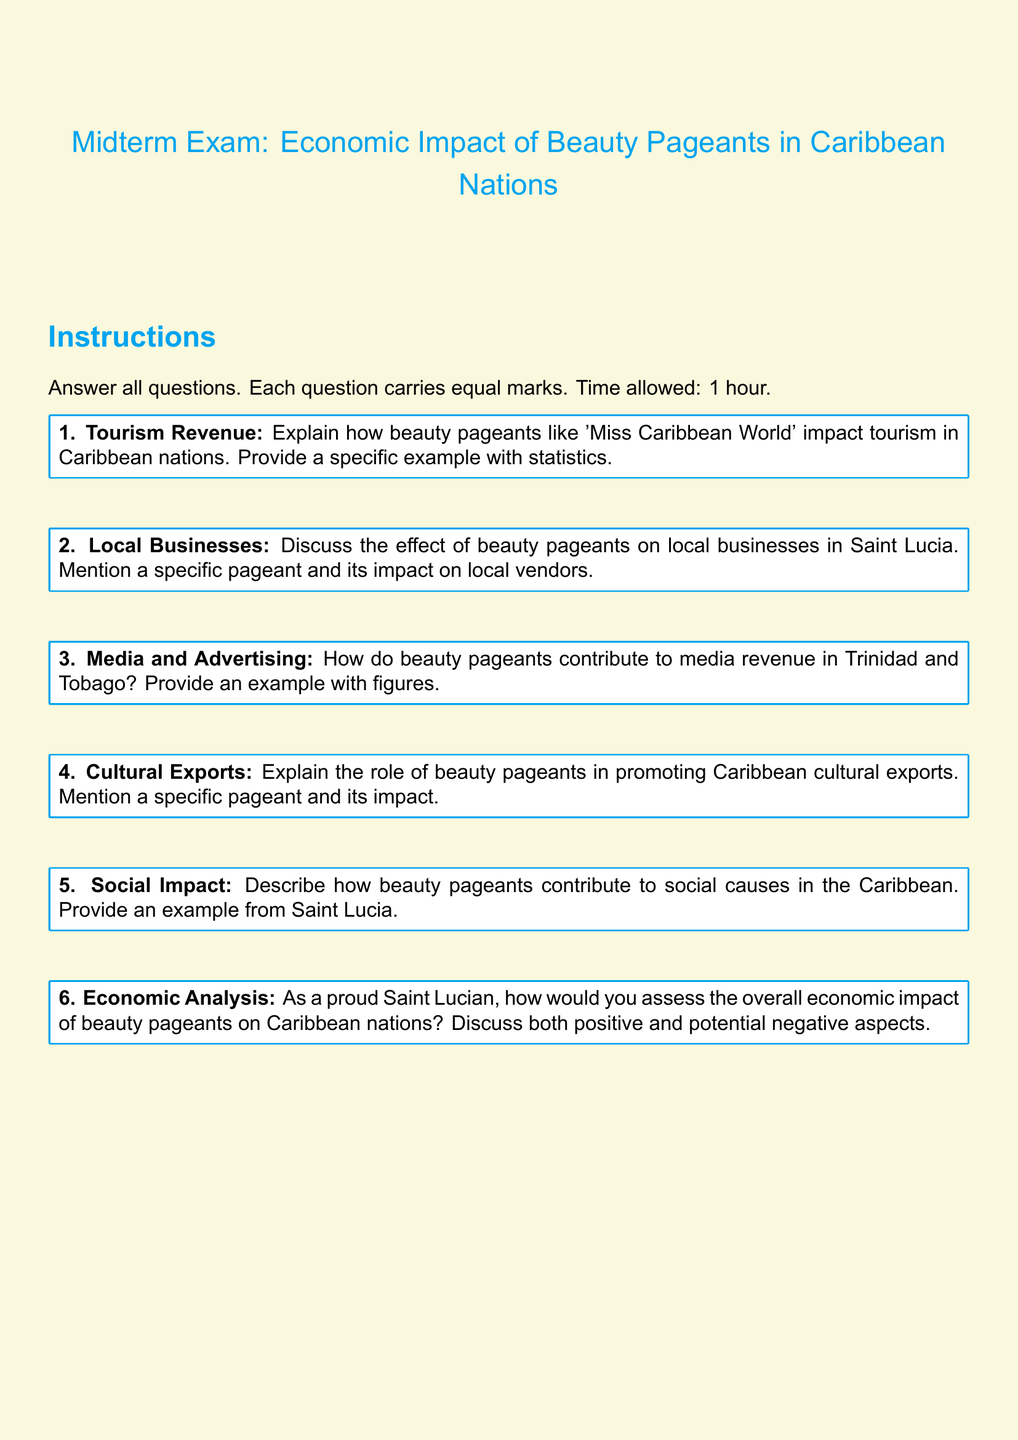What is the title of the document? The title of the document is the heading presented at the beginning of the content, specifying the topic of the midterm exam.
Answer: Midterm Exam: Economic Impact of Beauty Pageants in Caribbean Nations How many questions are included in the exam? The document outlines a specific number of questions that students are required to answer in the midterm exam.
Answer: 6 Which color is used for the title? The document specifies a color code for the title text, which is a part of the visual design elements.
Answer: Caribbean blue What is the time allowed for the exam? The document explicitly states the duration allocated for completing the midterm exam.
Answer: 1 hour What type of impact is discussed in relation to beauty pageants and local businesses? The document addresses the influence of beauty pageants on a specific economic sector within Caribbean nations.
Answer: Effect Which Caribbean nation is specifically mentioned in question two? The question directly refers to a country known for its participation in beauty pageants, specifically discussed in the context of local businesses.
Answer: Saint Lucia What social aspect is highlighted in question five? The focus of this question is on charitable activities or initiatives associated with beauty pageants in Caribbean nations.
Answer: Social causes What format is the document written in? The document utilizes a specific layout format characteristic of academic settings, particularly for assessments.
Answer: Article 